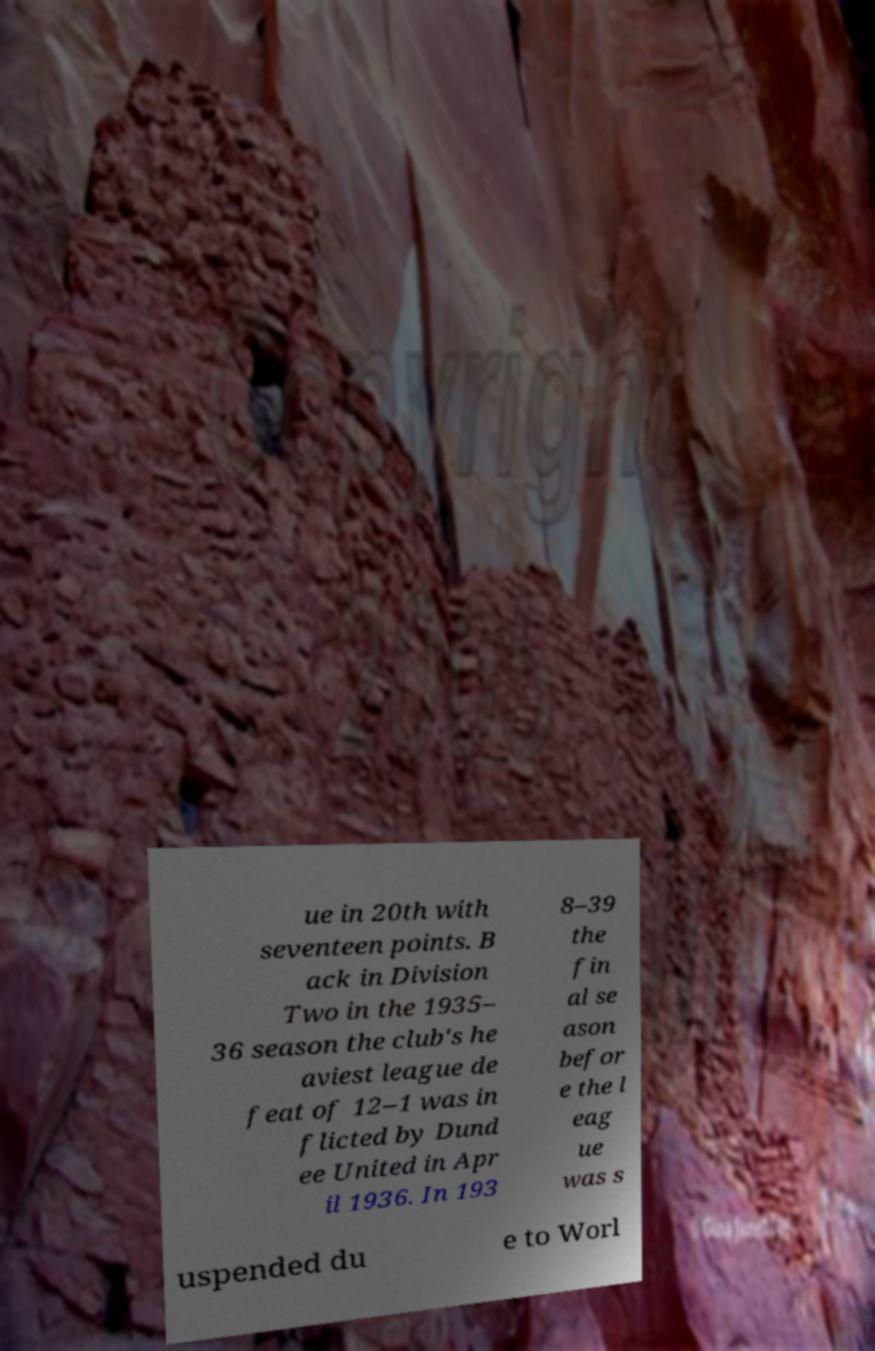Could you extract and type out the text from this image? ue in 20th with seventeen points. B ack in Division Two in the 1935– 36 season the club's he aviest league de feat of 12–1 was in flicted by Dund ee United in Apr il 1936. In 193 8–39 the fin al se ason befor e the l eag ue was s uspended du e to Worl 